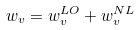Convert formula to latex. <formula><loc_0><loc_0><loc_500><loc_500>w _ { v } = w ^ { L O } _ { v } + w ^ { N L } _ { v }</formula> 